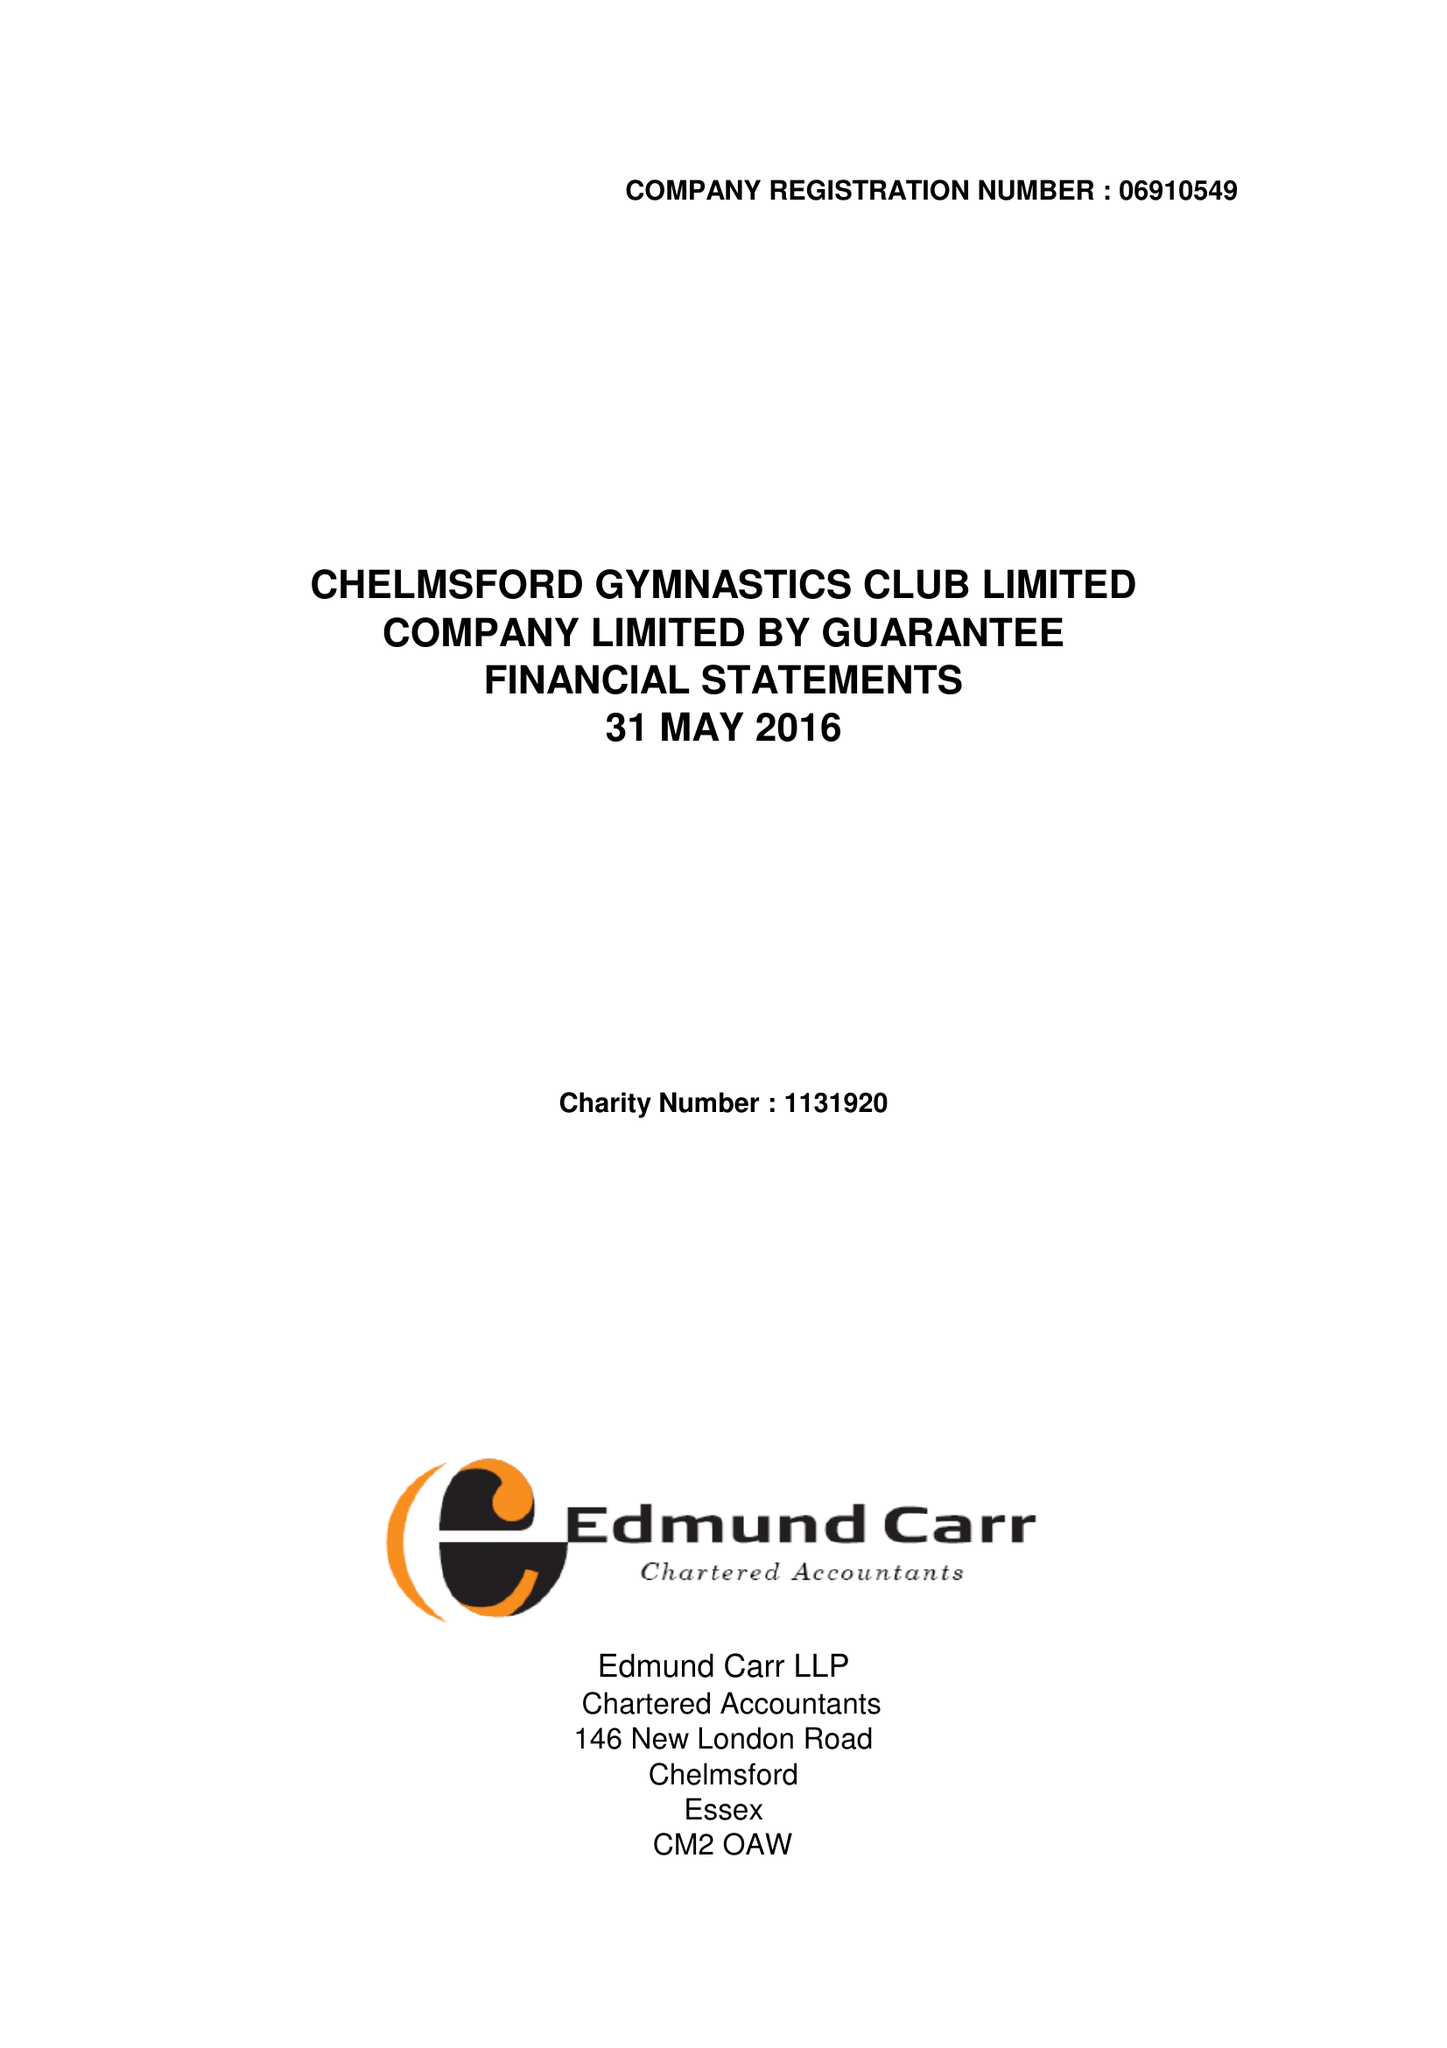What is the value for the charity_name?
Answer the question using a single word or phrase. Chelmsford Gymnastics Club Ltd. 